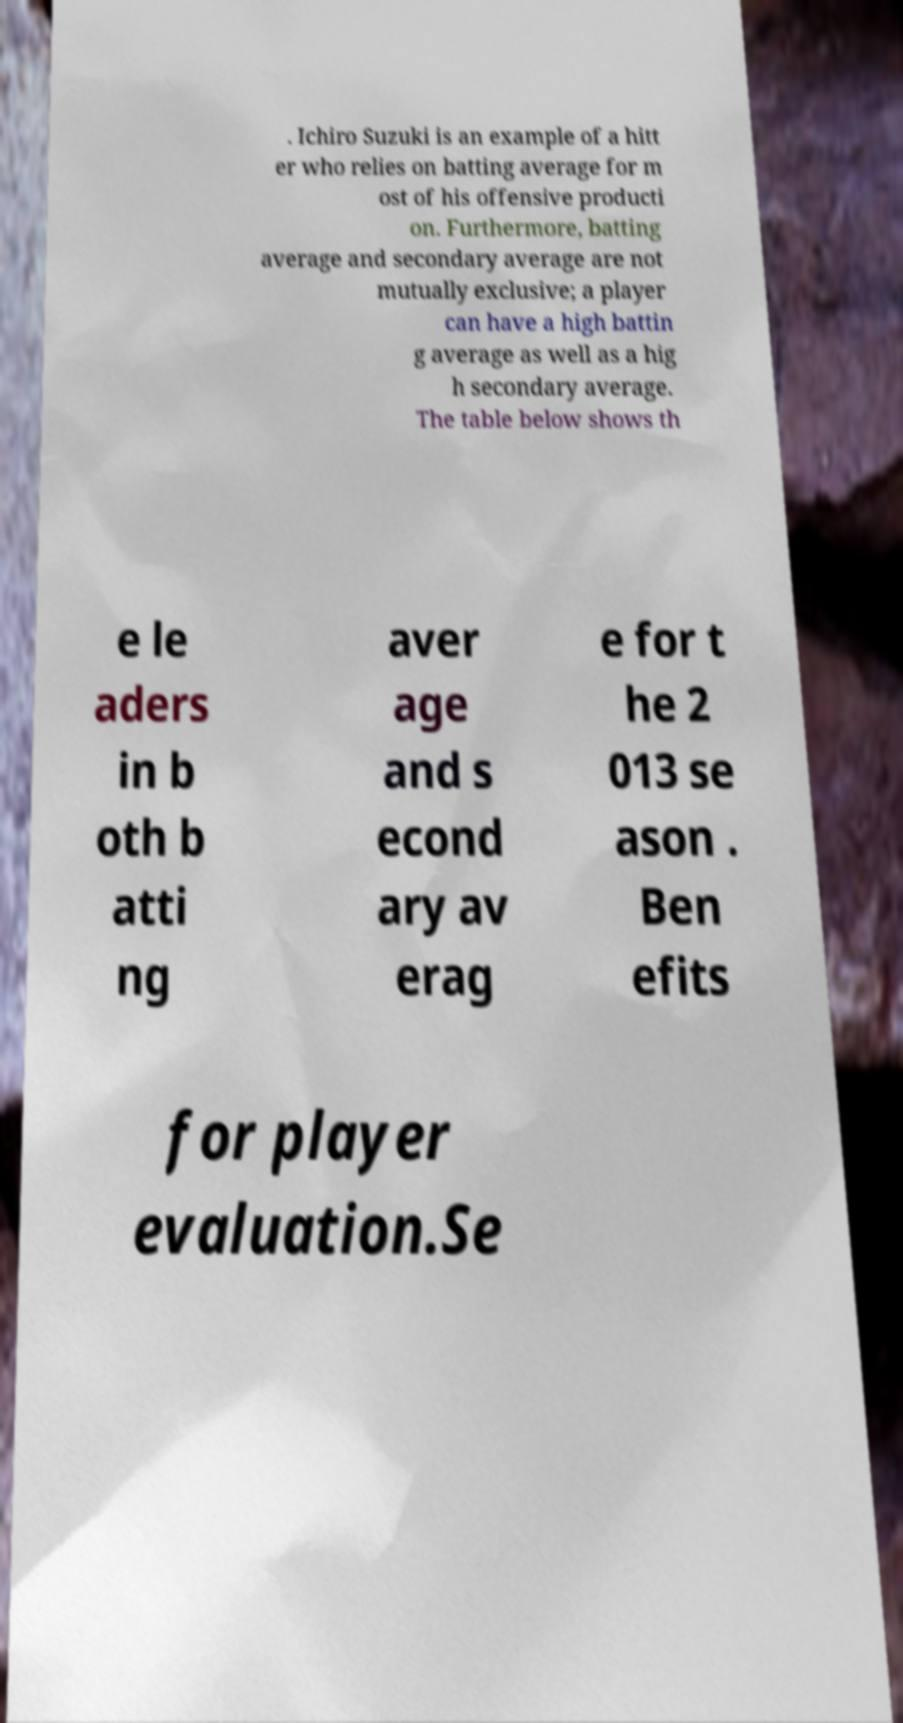Could you extract and type out the text from this image? . Ichiro Suzuki is an example of a hitt er who relies on batting average for m ost of his offensive producti on. Furthermore, batting average and secondary average are not mutually exclusive; a player can have a high battin g average as well as a hig h secondary average. The table below shows th e le aders in b oth b atti ng aver age and s econd ary av erag e for t he 2 013 se ason . Ben efits for player evaluation.Se 